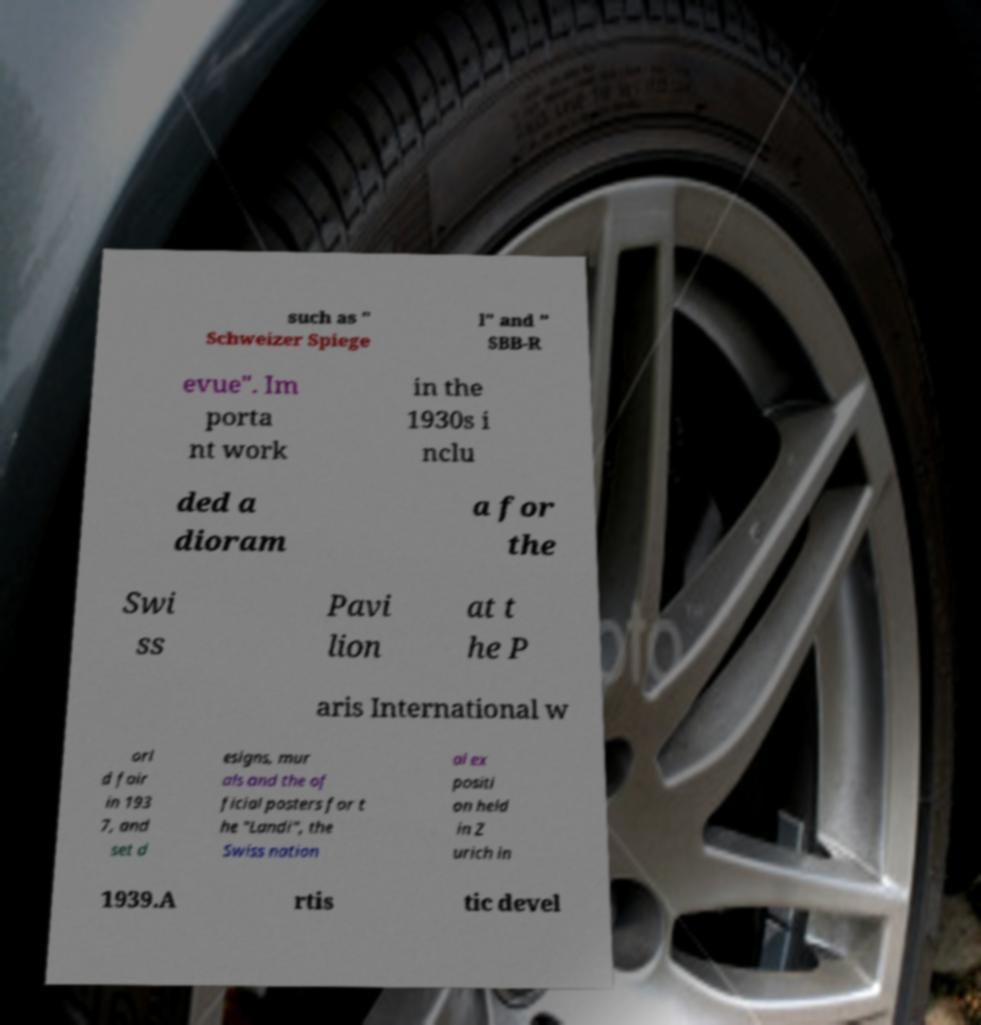There's text embedded in this image that I need extracted. Can you transcribe it verbatim? such as " Schweizer Spiege l" and " SBB-R evue". Im porta nt work in the 1930s i nclu ded a dioram a for the Swi ss Pavi lion at t he P aris International w orl d fair in 193 7, and set d esigns, mur als and the of ficial posters for t he "Landi", the Swiss nation al ex positi on held in Z urich in 1939.A rtis tic devel 